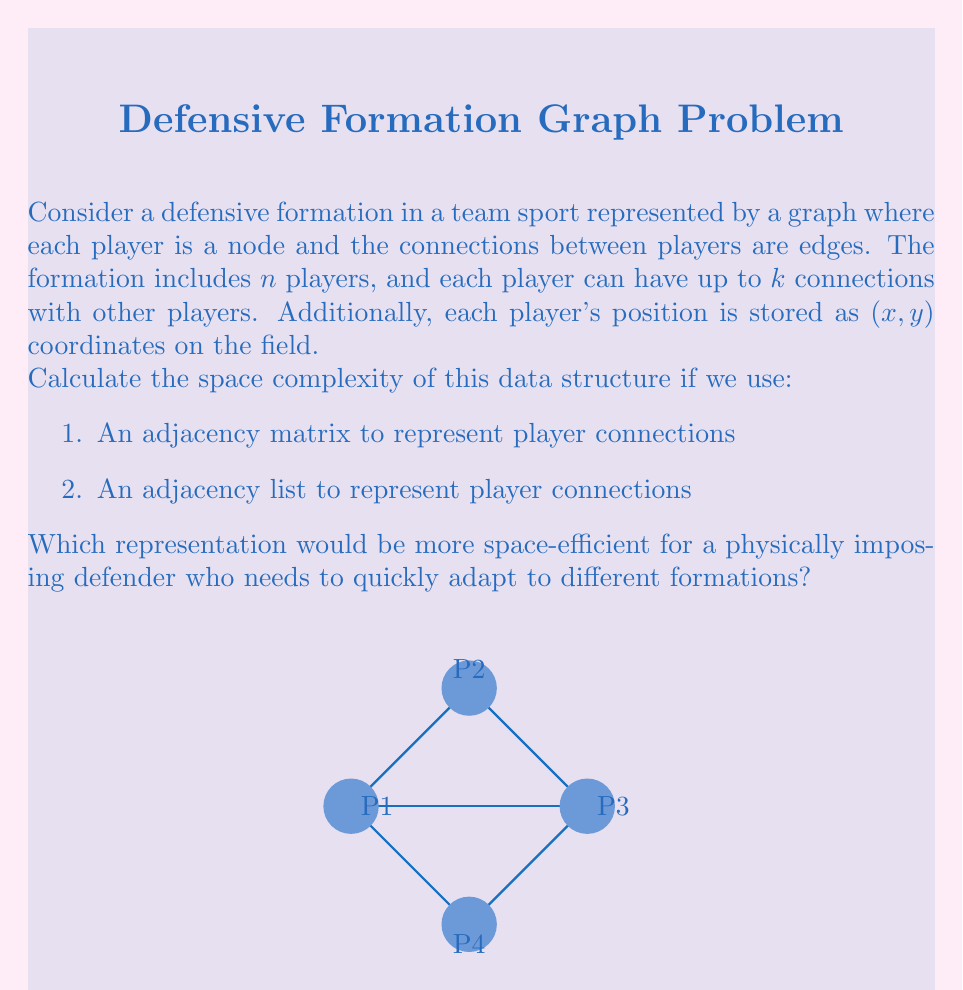What is the answer to this math problem? Let's analyze the space complexity for both representations:

1. Adjacency Matrix:
   - The matrix will have dimensions $n \times n$, where $n$ is the number of players.
   - Each cell in the matrix requires 1 bit (0 or 1) to represent a connection.
   - Total space for connections: $O(n^2)$ bits or $O(n^2)$ space complexity.
   - For player positions, we need to store $(x, y)$ coordinates for each player:
     $n \times 2$ values, each typically stored as a float (4 bytes).
   - Total space for positions: $8n$ bytes or $O(n)$ space complexity.
   - Overall space complexity: $O(n^2 + n) = O(n^2)$

2. Adjacency List:
   - For each player, we store a list of connected players.
   - Each player can have at most $k$ connections.
   - Total space for connections: $O(nk)$ space complexity.
   - Player positions are stored the same way as in the matrix representation:
     $O(n)$ space complexity.
   - Overall space complexity: $O(nk + n) = O(nk)$

For a physically imposing defender who needs to quickly adapt to different formations:
- If $k < n$, the adjacency list representation is more space-efficient: $O(nk)$ vs $O(n^2)$.
- In most team sports, $k$ is typically much smaller than $n$. For example, in soccer with 11 players, a defender might have direct connections with 3-5 other players.
- The adjacency list also allows for faster iteration over a player's connections, which is beneficial for quick adaptation.

Therefore, the adjacency list representation would be more space-efficient and suitable for the defender's needs.
Answer: $O(nk)$ using adjacency list, where $n$ is the number of players and $k$ is the maximum connections per player. 